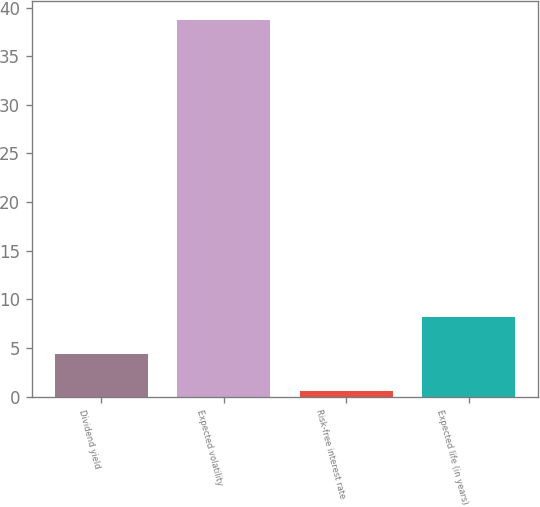Convert chart to OTSL. <chart><loc_0><loc_0><loc_500><loc_500><bar_chart><fcel>Dividend yield<fcel>Expected volatility<fcel>Risk-free interest rate<fcel>Expected life (in years)<nl><fcel>4.34<fcel>38.7<fcel>0.52<fcel>8.16<nl></chart> 